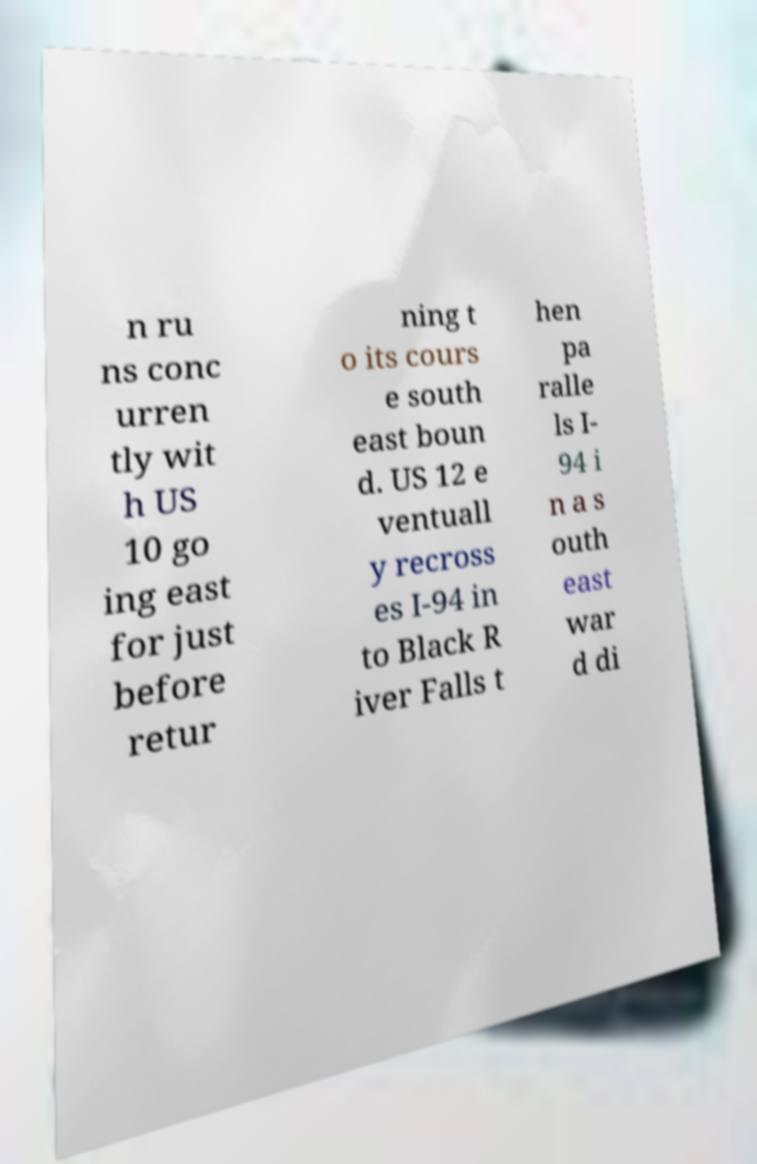There's text embedded in this image that I need extracted. Can you transcribe it verbatim? n ru ns conc urren tly wit h US 10 go ing east for just before retur ning t o its cours e south east boun d. US 12 e ventuall y recross es I-94 in to Black R iver Falls t hen pa ralle ls I- 94 i n a s outh east war d di 